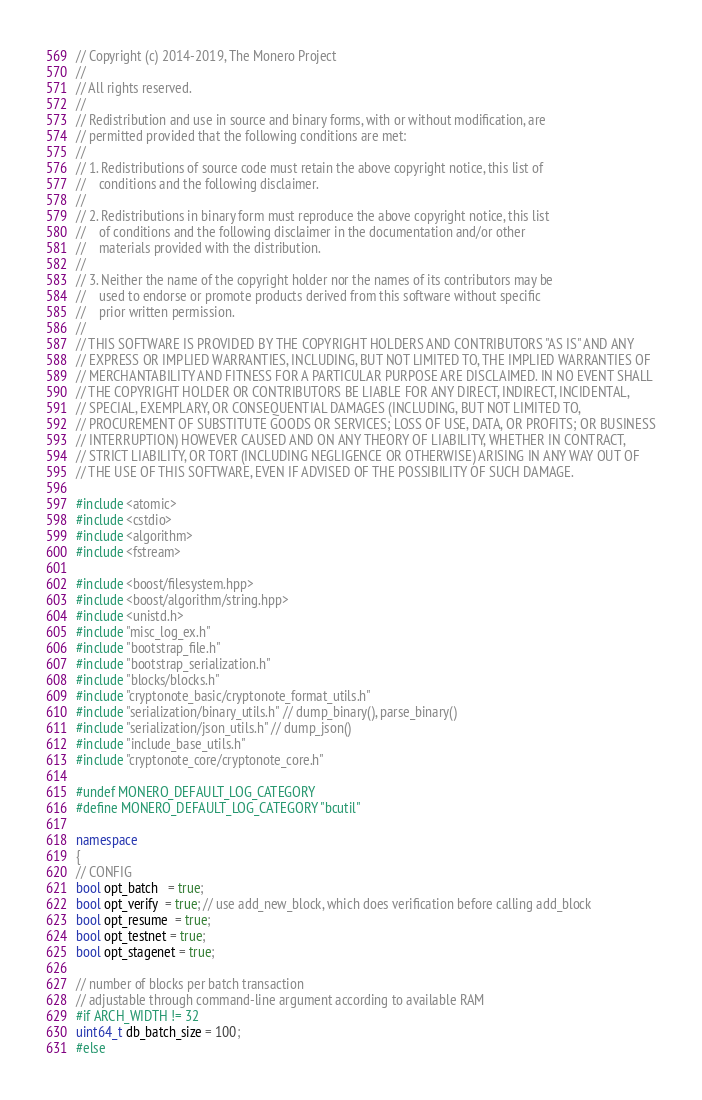Convert code to text. <code><loc_0><loc_0><loc_500><loc_500><_C++_>// Copyright (c) 2014-2019, The Monero Project
//
// All rights reserved.
//
// Redistribution and use in source and binary forms, with or without modification, are
// permitted provided that the following conditions are met:
//
// 1. Redistributions of source code must retain the above copyright notice, this list of
//    conditions and the following disclaimer.
//
// 2. Redistributions in binary form must reproduce the above copyright notice, this list
//    of conditions and the following disclaimer in the documentation and/or other
//    materials provided with the distribution.
//
// 3. Neither the name of the copyright holder nor the names of its contributors may be
//    used to endorse or promote products derived from this software without specific
//    prior written permission.
//
// THIS SOFTWARE IS PROVIDED BY THE COPYRIGHT HOLDERS AND CONTRIBUTORS "AS IS" AND ANY
// EXPRESS OR IMPLIED WARRANTIES, INCLUDING, BUT NOT LIMITED TO, THE IMPLIED WARRANTIES OF
// MERCHANTABILITY AND FITNESS FOR A PARTICULAR PURPOSE ARE DISCLAIMED. IN NO EVENT SHALL
// THE COPYRIGHT HOLDER OR CONTRIBUTORS BE LIABLE FOR ANY DIRECT, INDIRECT, INCIDENTAL,
// SPECIAL, EXEMPLARY, OR CONSEQUENTIAL DAMAGES (INCLUDING, BUT NOT LIMITED TO,
// PROCUREMENT OF SUBSTITUTE GOODS OR SERVICES; LOSS OF USE, DATA, OR PROFITS; OR BUSINESS
// INTERRUPTION) HOWEVER CAUSED AND ON ANY THEORY OF LIABILITY, WHETHER IN CONTRACT,
// STRICT LIABILITY, OR TORT (INCLUDING NEGLIGENCE OR OTHERWISE) ARISING IN ANY WAY OUT OF
// THE USE OF THIS SOFTWARE, EVEN IF ADVISED OF THE POSSIBILITY OF SUCH DAMAGE.

#include <atomic>
#include <cstdio>
#include <algorithm>
#include <fstream>

#include <boost/filesystem.hpp>
#include <boost/algorithm/string.hpp>
#include <unistd.h>
#include "misc_log_ex.h"
#include "bootstrap_file.h"
#include "bootstrap_serialization.h"
#include "blocks/blocks.h"
#include "cryptonote_basic/cryptonote_format_utils.h"
#include "serialization/binary_utils.h" // dump_binary(), parse_binary()
#include "serialization/json_utils.h" // dump_json()
#include "include_base_utils.h"
#include "cryptonote_core/cryptonote_core.h"

#undef MONERO_DEFAULT_LOG_CATEGORY
#define MONERO_DEFAULT_LOG_CATEGORY "bcutil"

namespace
{
// CONFIG
bool opt_batch   = true;
bool opt_verify  = true; // use add_new_block, which does verification before calling add_block
bool opt_resume  = true;
bool opt_testnet = true;
bool opt_stagenet = true;

// number of blocks per batch transaction
// adjustable through command-line argument according to available RAM
#if ARCH_WIDTH != 32
uint64_t db_batch_size = 100;
#else</code> 